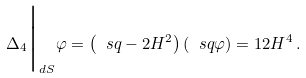<formula> <loc_0><loc_0><loc_500><loc_500>\Delta _ { 4 } \Big | _ { d S } \varphi = \left ( \ s q - 2 H ^ { 2 } \right ) ( \ s q \varphi ) = 1 2 H ^ { 4 } \, .</formula> 